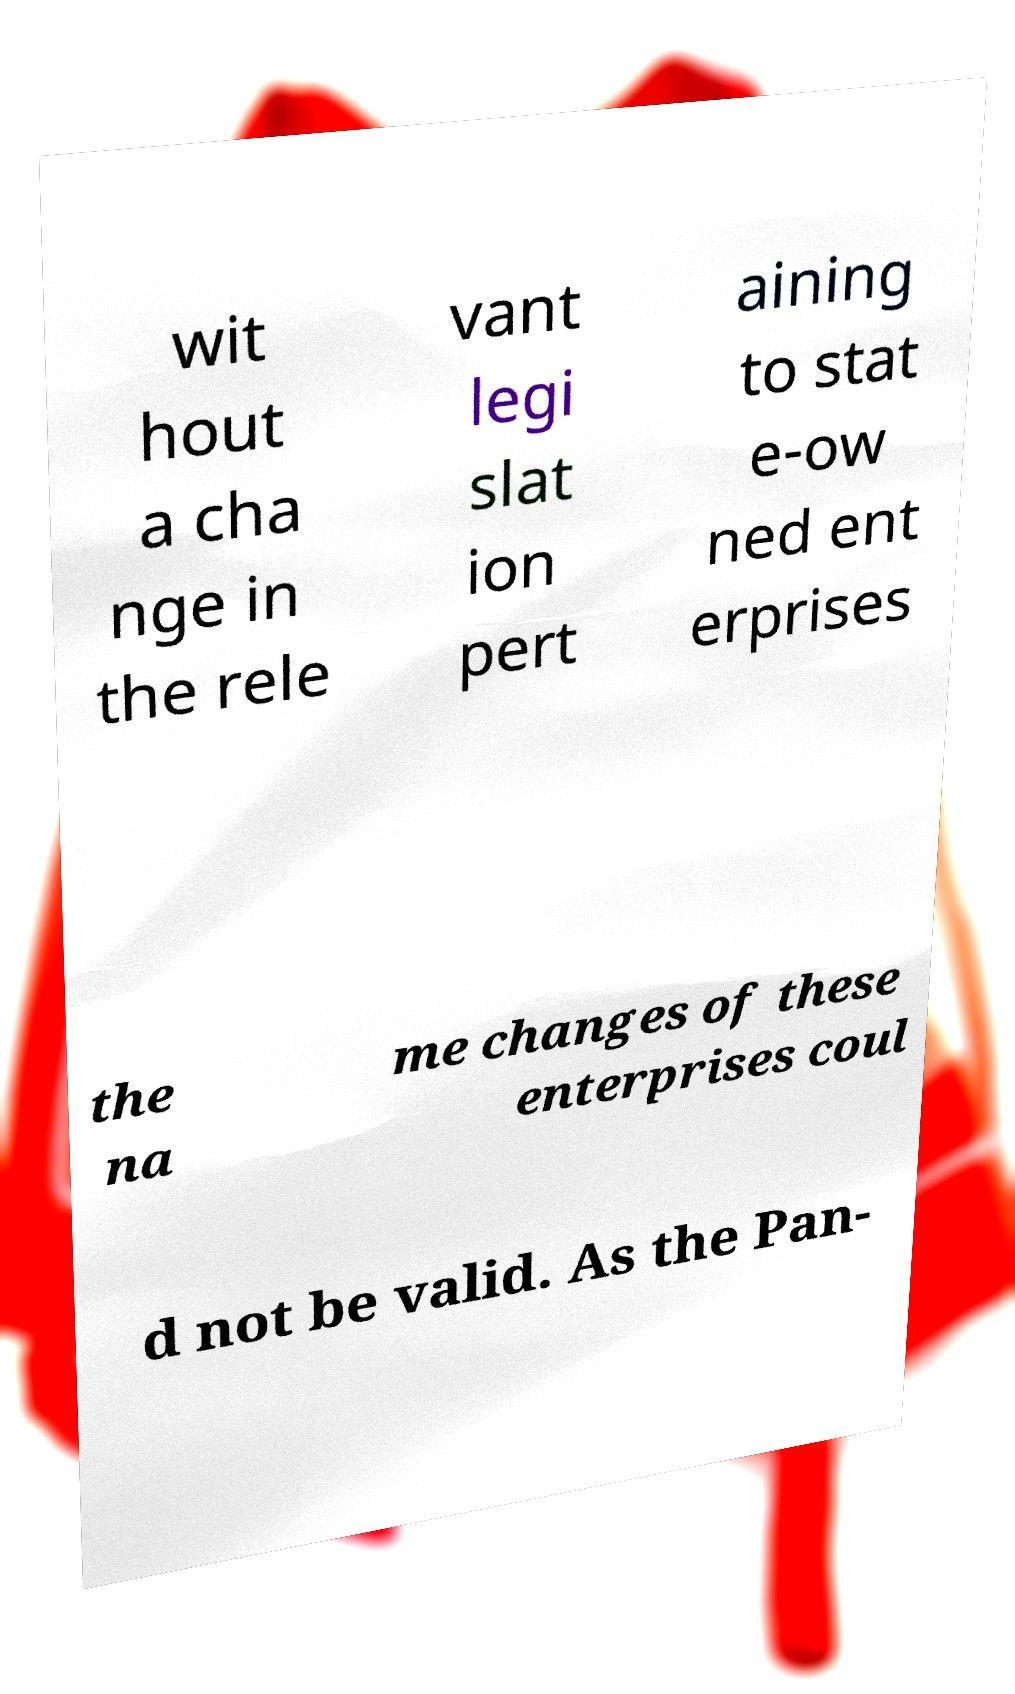Please read and relay the text visible in this image. What does it say? wit hout a cha nge in the rele vant legi slat ion pert aining to stat e-ow ned ent erprises the na me changes of these enterprises coul d not be valid. As the Pan- 